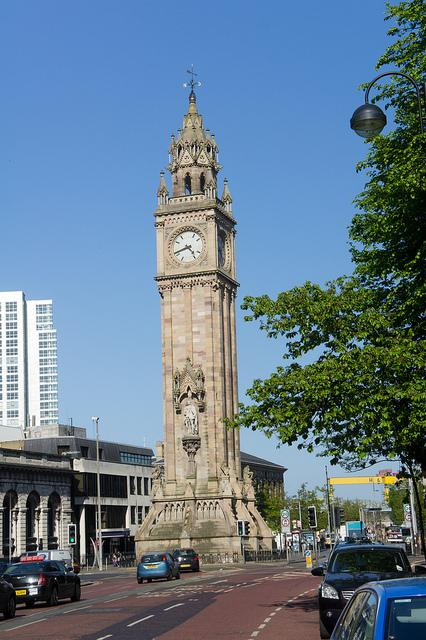What is near the tower?

Choices:
A) car
B) airplane
C) princess
D) baby car 